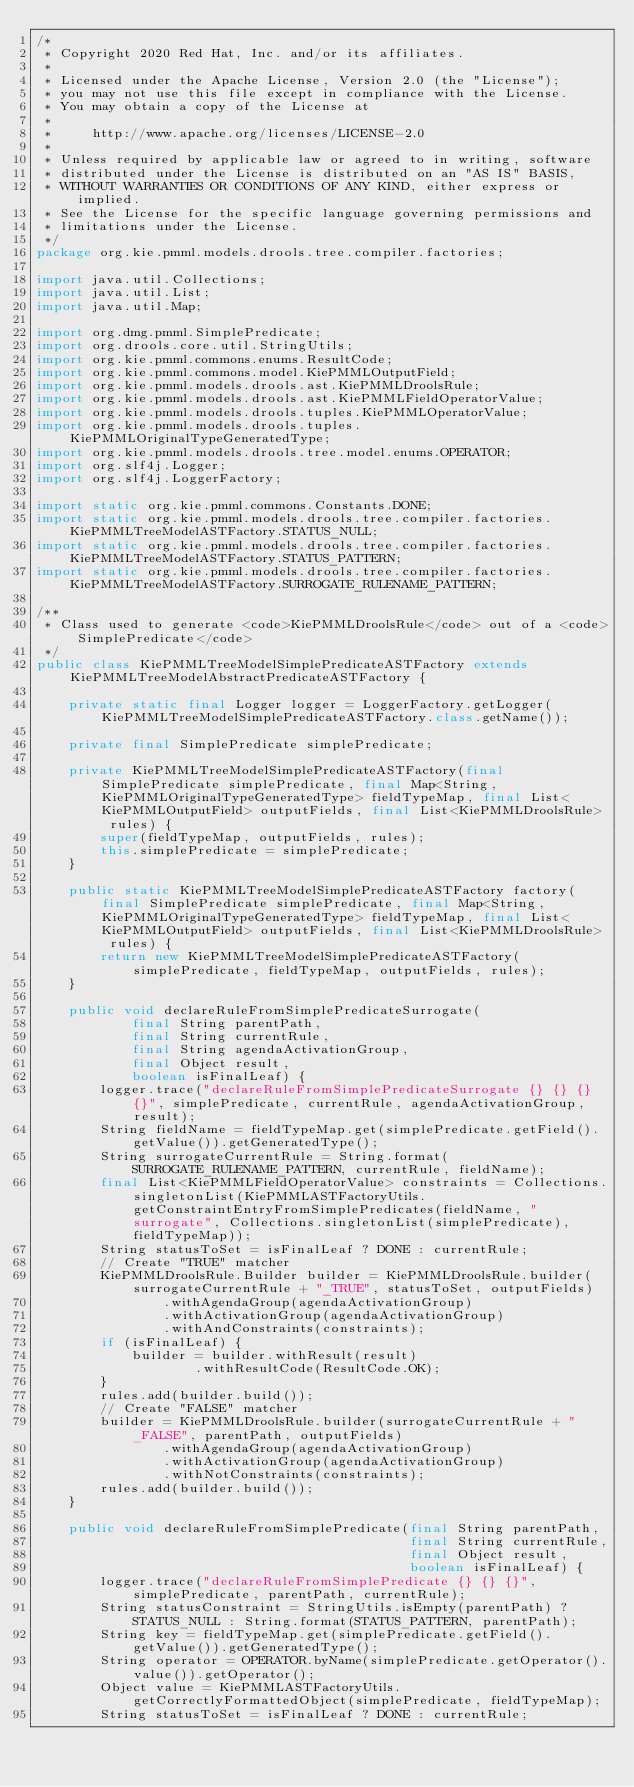Convert code to text. <code><loc_0><loc_0><loc_500><loc_500><_Java_>/*
 * Copyright 2020 Red Hat, Inc. and/or its affiliates.
 *
 * Licensed under the Apache License, Version 2.0 (the "License");
 * you may not use this file except in compliance with the License.
 * You may obtain a copy of the License at
 *
 *     http://www.apache.org/licenses/LICENSE-2.0
 *
 * Unless required by applicable law or agreed to in writing, software
 * distributed under the License is distributed on an "AS IS" BASIS,
 * WITHOUT WARRANTIES OR CONDITIONS OF ANY KIND, either express or implied.
 * See the License for the specific language governing permissions and
 * limitations under the License.
 */
package org.kie.pmml.models.drools.tree.compiler.factories;

import java.util.Collections;
import java.util.List;
import java.util.Map;

import org.dmg.pmml.SimplePredicate;
import org.drools.core.util.StringUtils;
import org.kie.pmml.commons.enums.ResultCode;
import org.kie.pmml.commons.model.KiePMMLOutputField;
import org.kie.pmml.models.drools.ast.KiePMMLDroolsRule;
import org.kie.pmml.models.drools.ast.KiePMMLFieldOperatorValue;
import org.kie.pmml.models.drools.tuples.KiePMMLOperatorValue;
import org.kie.pmml.models.drools.tuples.KiePMMLOriginalTypeGeneratedType;
import org.kie.pmml.models.drools.tree.model.enums.OPERATOR;
import org.slf4j.Logger;
import org.slf4j.LoggerFactory;

import static org.kie.pmml.commons.Constants.DONE;
import static org.kie.pmml.models.drools.tree.compiler.factories.KiePMMLTreeModelASTFactory.STATUS_NULL;
import static org.kie.pmml.models.drools.tree.compiler.factories.KiePMMLTreeModelASTFactory.STATUS_PATTERN;
import static org.kie.pmml.models.drools.tree.compiler.factories.KiePMMLTreeModelASTFactory.SURROGATE_RULENAME_PATTERN;

/**
 * Class used to generate <code>KiePMMLDroolsRule</code> out of a <code>SimplePredicate</code>
 */
public class KiePMMLTreeModelSimplePredicateASTFactory extends KiePMMLTreeModelAbstractPredicateASTFactory {

    private static final Logger logger = LoggerFactory.getLogger(KiePMMLTreeModelSimplePredicateASTFactory.class.getName());

    private final SimplePredicate simplePredicate;

    private KiePMMLTreeModelSimplePredicateASTFactory(final SimplePredicate simplePredicate, final Map<String, KiePMMLOriginalTypeGeneratedType> fieldTypeMap, final List<KiePMMLOutputField> outputFields, final List<KiePMMLDroolsRule> rules) {
        super(fieldTypeMap, outputFields, rules);
        this.simplePredicate = simplePredicate;
    }

    public static KiePMMLTreeModelSimplePredicateASTFactory factory(final SimplePredicate simplePredicate, final Map<String, KiePMMLOriginalTypeGeneratedType> fieldTypeMap, final List<KiePMMLOutputField> outputFields, final List<KiePMMLDroolsRule> rules) {
        return new KiePMMLTreeModelSimplePredicateASTFactory(simplePredicate, fieldTypeMap, outputFields, rules);
    }

    public void declareRuleFromSimplePredicateSurrogate(
            final String parentPath,
            final String currentRule,
            final String agendaActivationGroup,
            final Object result,
            boolean isFinalLeaf) {
        logger.trace("declareRuleFromSimplePredicateSurrogate {} {} {} {}", simplePredicate, currentRule, agendaActivationGroup, result);
        String fieldName = fieldTypeMap.get(simplePredicate.getField().getValue()).getGeneratedType();
        String surrogateCurrentRule = String.format(SURROGATE_RULENAME_PATTERN, currentRule, fieldName);
        final List<KiePMMLFieldOperatorValue> constraints = Collections.singletonList(KiePMMLASTFactoryUtils.getConstraintEntryFromSimplePredicates(fieldName, "surrogate", Collections.singletonList(simplePredicate), fieldTypeMap));
        String statusToSet = isFinalLeaf ? DONE : currentRule;
        // Create "TRUE" matcher
        KiePMMLDroolsRule.Builder builder = KiePMMLDroolsRule.builder(surrogateCurrentRule + "_TRUE", statusToSet, outputFields)
                .withAgendaGroup(agendaActivationGroup)
                .withActivationGroup(agendaActivationGroup)
                .withAndConstraints(constraints);
        if (isFinalLeaf) {
            builder = builder.withResult(result)
                    .withResultCode(ResultCode.OK);
        }
        rules.add(builder.build());
        // Create "FALSE" matcher
        builder = KiePMMLDroolsRule.builder(surrogateCurrentRule + "_FALSE", parentPath, outputFields)
                .withAgendaGroup(agendaActivationGroup)
                .withActivationGroup(agendaActivationGroup)
                .withNotConstraints(constraints);
        rules.add(builder.build());
    }

    public void declareRuleFromSimplePredicate(final String parentPath,
                                               final String currentRule,
                                               final Object result,
                                               boolean isFinalLeaf) {
        logger.trace("declareRuleFromSimplePredicate {} {} {}", simplePredicate, parentPath, currentRule);
        String statusConstraint = StringUtils.isEmpty(parentPath) ? STATUS_NULL : String.format(STATUS_PATTERN, parentPath);
        String key = fieldTypeMap.get(simplePredicate.getField().getValue()).getGeneratedType();
        String operator = OPERATOR.byName(simplePredicate.getOperator().value()).getOperator();
        Object value = KiePMMLASTFactoryUtils.getCorrectlyFormattedObject(simplePredicate, fieldTypeMap);
        String statusToSet = isFinalLeaf ? DONE : currentRule;</code> 